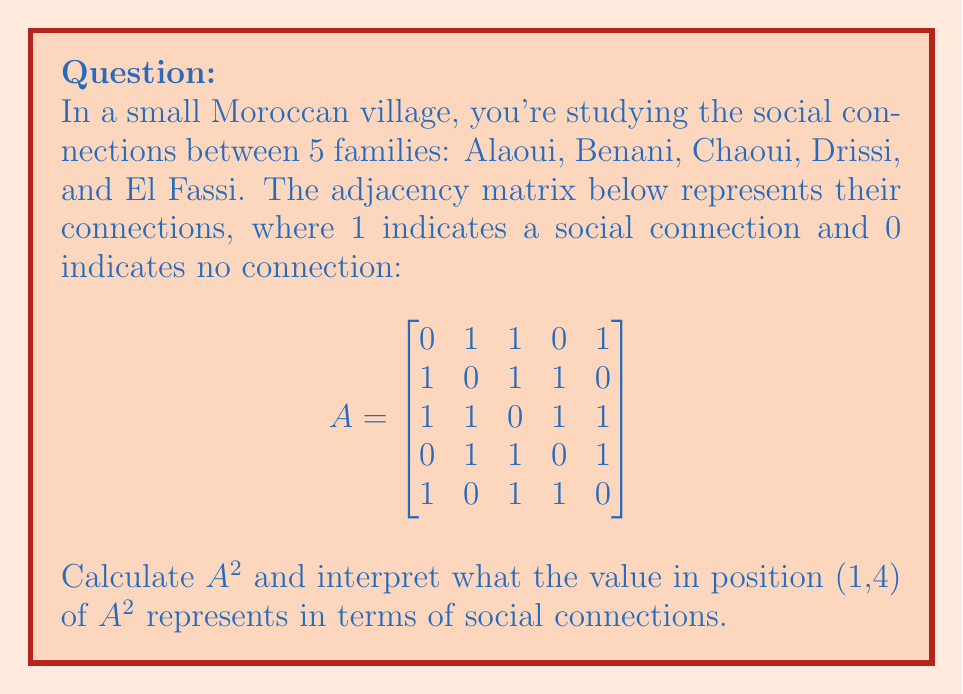What is the answer to this math problem? Let's approach this step-by-step:

1) First, we need to calculate $A^2$. This is done by multiplying matrix A by itself.

2) The general formula for matrix multiplication is:
   $$(A^2)_{ij} = \sum_{k=1}^n A_{ik}A_{kj}$$

3) Let's calculate the value at position (1,4) of $A^2$:
   $$(A^2)_{14} = (0 \cdot 0) + (1 \cdot 1) + (1 \cdot 1) + (0 \cdot 0) + (1 \cdot 1) = 0 + 1 + 1 + 0 + 1 = 3$$

4) Interpretation: In social network analysis, the value in $A^2$ represents the number of paths of length 2 between two nodes (families in this case).

5) Therefore, the value 3 in position (1,4) of $A^2$ means there are 3 different paths of length 2 connecting the Alaoui family (1st row) to the Drissi family (4th column).

6) These paths are:
   - Alaoui → Benani → Drissi
   - Alaoui → Chaoui → Drissi
   - Alaoui → El Fassi → Drissi

7) This indicates that while the Alaoui and Drissi families are not directly connected (as shown by the 0 in $A_{14}$), they have three mutual connections through other families.
Answer: 3; representing the number of 2-step paths between Alaoui and Drissi families. 